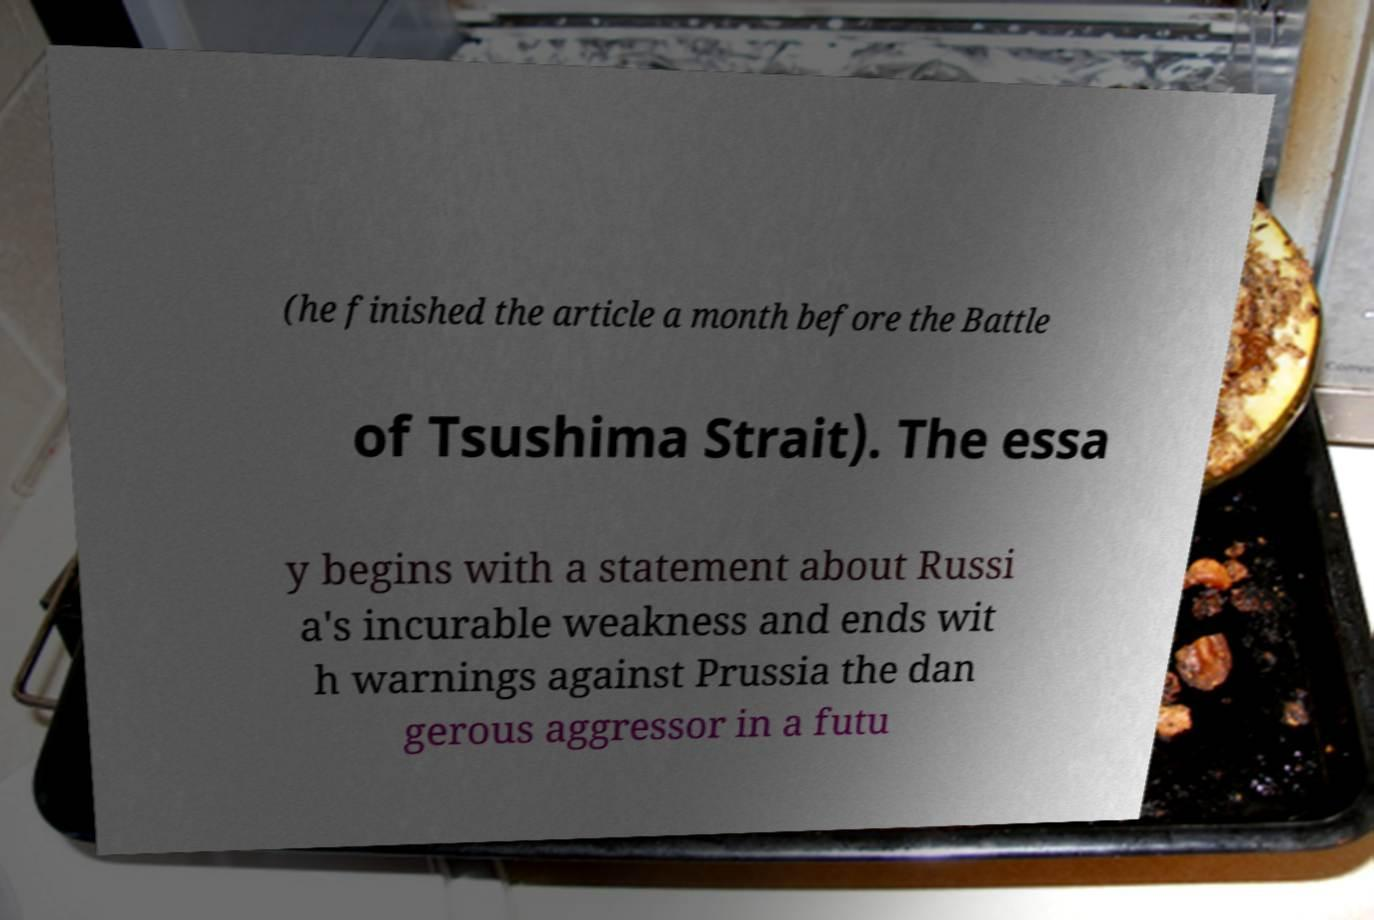Can you read and provide the text displayed in the image?This photo seems to have some interesting text. Can you extract and type it out for me? (he finished the article a month before the Battle of Tsushima Strait). The essa y begins with a statement about Russi a's incurable weakness and ends wit h warnings against Prussia the dan gerous aggressor in a futu 